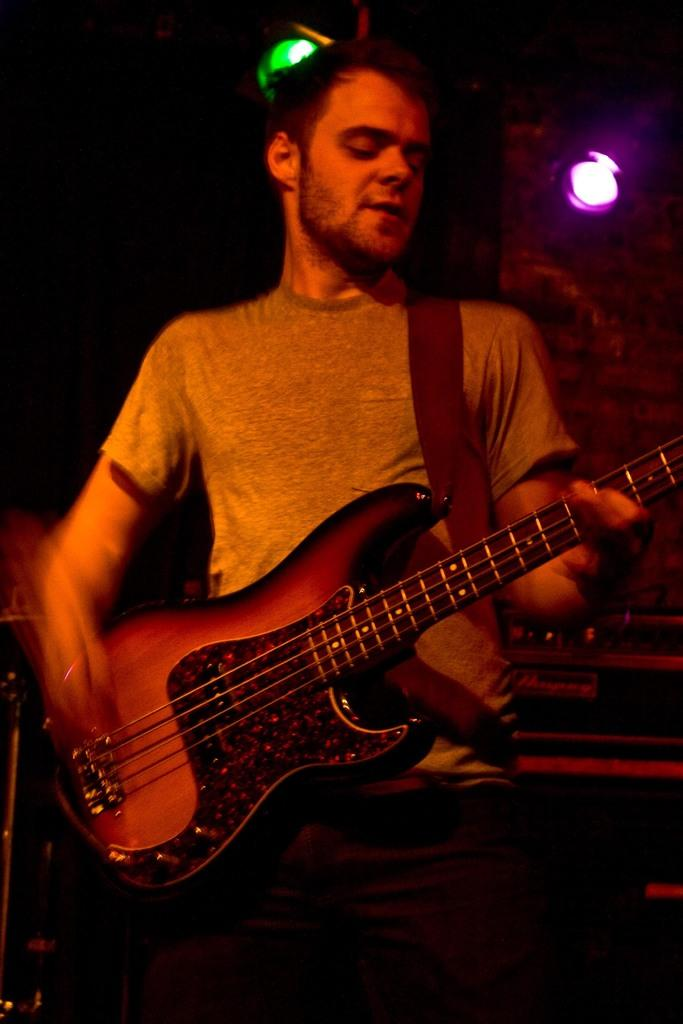What is the main subject of the image? The main subject of the image is a man. What is the man doing in the image? The man is standing in the image. What object is the man holding in the image? The man is holding a guitar in his hand. What historical discovery is the man making in the image? There is no indication of a historical discovery in the image; the man is simply standing and holding a guitar. 